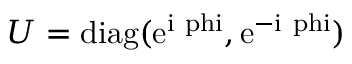<formula> <loc_0><loc_0><loc_500><loc_500>U = { d i a g } ( e ^ { i \ p h i } , e ^ { - i \ p h i } )</formula> 